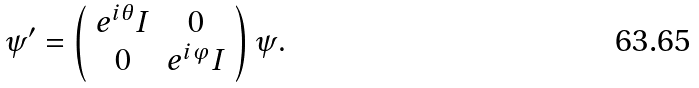<formula> <loc_0><loc_0><loc_500><loc_500>\psi ^ { \prime } = \left ( \begin{array} { c c } { { e ^ { i \theta } I } } & { 0 } \\ { 0 } & { { e ^ { i \varphi } I } } \end{array} \right ) \psi .</formula> 